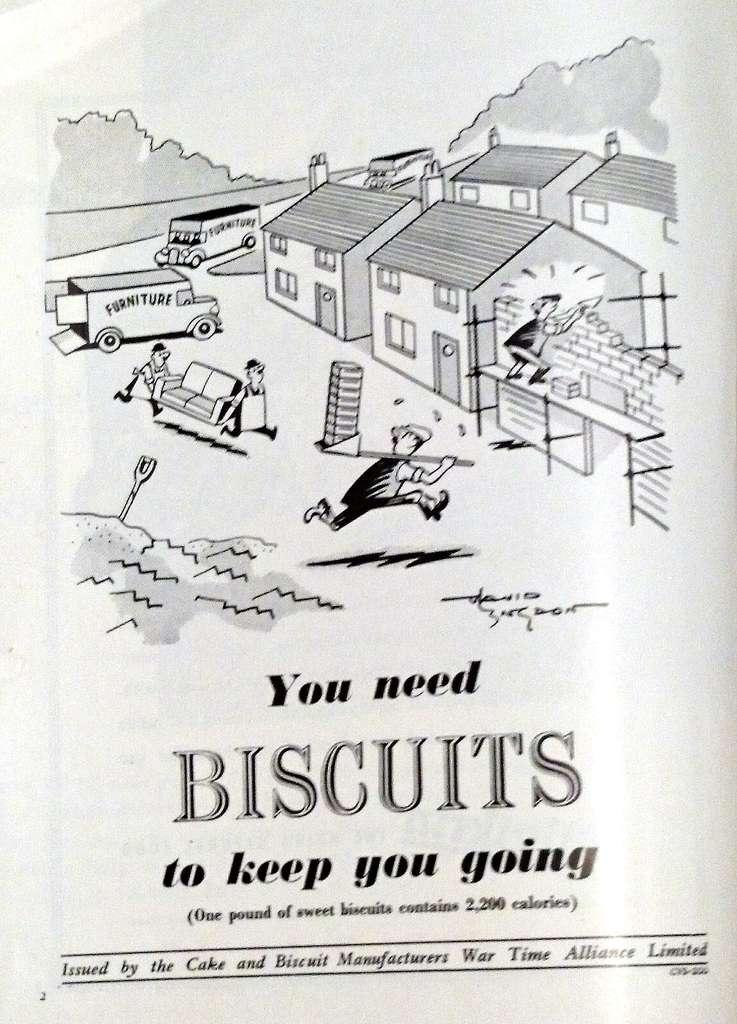What is the main subject of the paper in the image? The paper contains drawings of houses, vehicles, and persons. What are the persons in the drawings doing? The drawings show persons carrying objects. Is there any text on the paper? Yes, there is text at the bottom of the paper. What type of mouth can be seen on the polish in the image? There is no polish present in the image, and therefore no mouth can be seen on it. How does the memory affect the drawings on the paper? The image does not provide any information about the memory of the person who drew the images, so we cannot determine how it might have affected the drawings. 